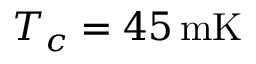Convert formula to latex. <formula><loc_0><loc_0><loc_500><loc_500>T _ { c } = 4 5 \, m K</formula> 